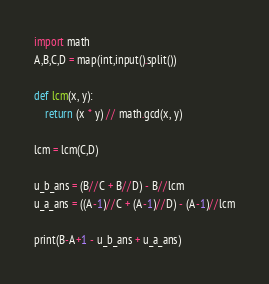Convert code to text. <code><loc_0><loc_0><loc_500><loc_500><_Python_>import math
A,B,C,D = map(int,input().split())

def lcm(x, y):
    return (x * y) // math.gcd(x, y)

lcm = lcm(C,D)

u_b_ans = (B//C + B//D) - B//lcm
u_a_ans = ((A-1)//C + (A-1)//D) - (A-1)//lcm

print(B-A+1 - u_b_ans + u_a_ans)
</code> 